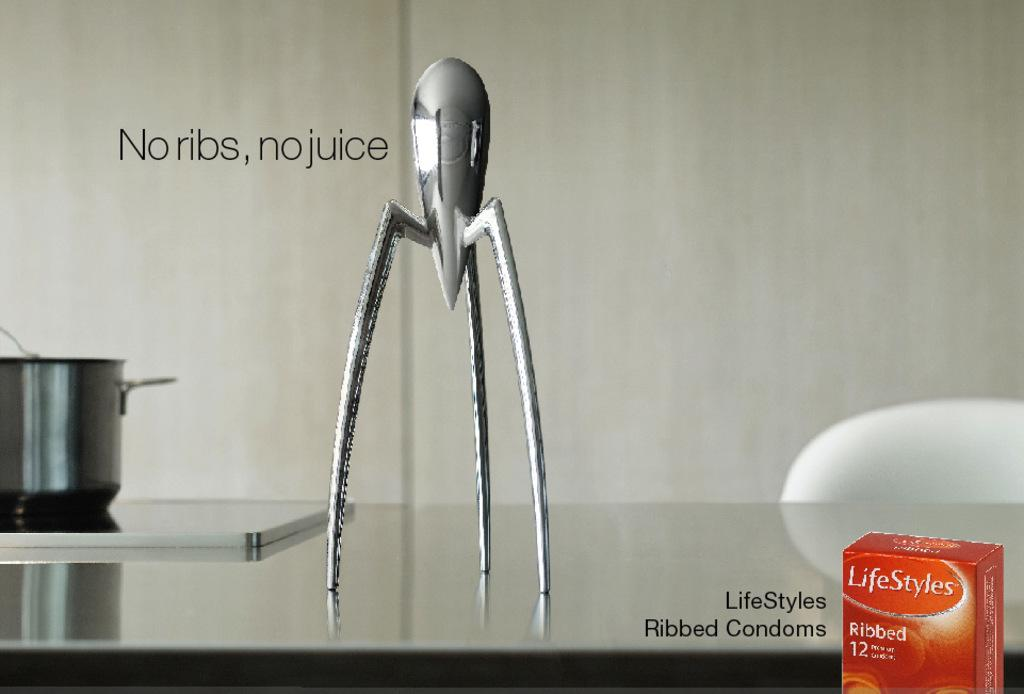Provide a one-sentence caption for the provided image. Ad for Lifestyles condoms that says "No ribs, no juice". 